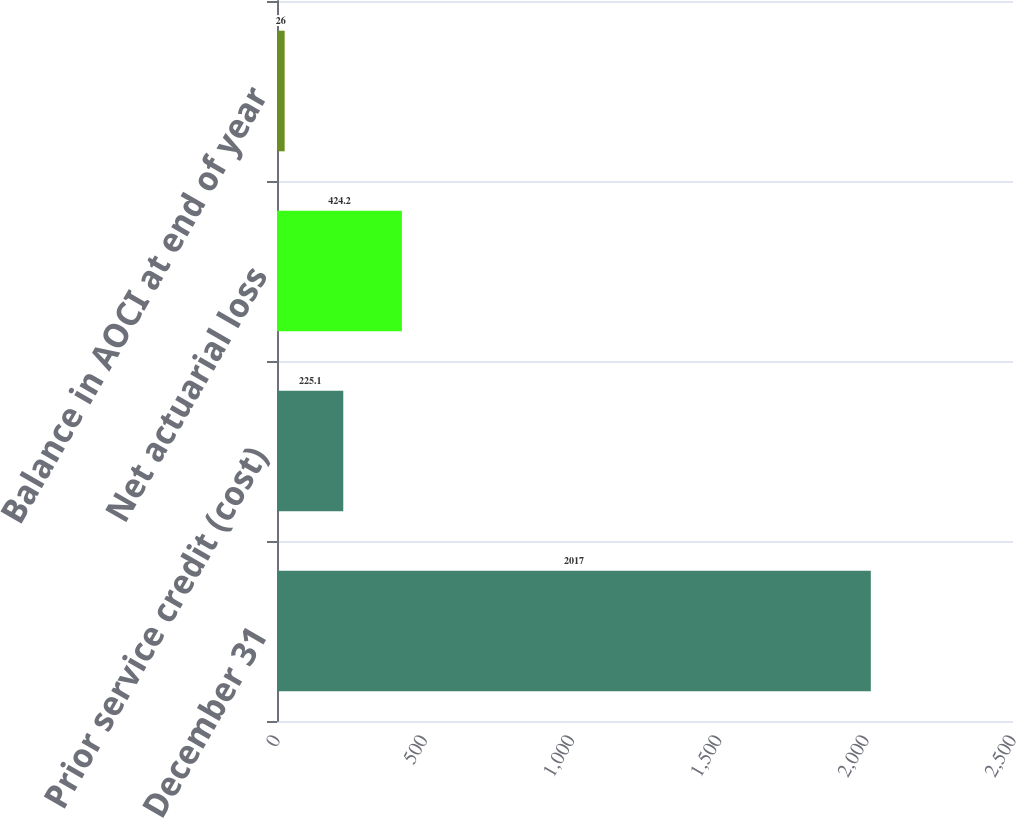Convert chart to OTSL. <chart><loc_0><loc_0><loc_500><loc_500><bar_chart><fcel>December 31<fcel>Prior service credit (cost)<fcel>Net actuarial loss<fcel>Balance in AOCI at end of year<nl><fcel>2017<fcel>225.1<fcel>424.2<fcel>26<nl></chart> 